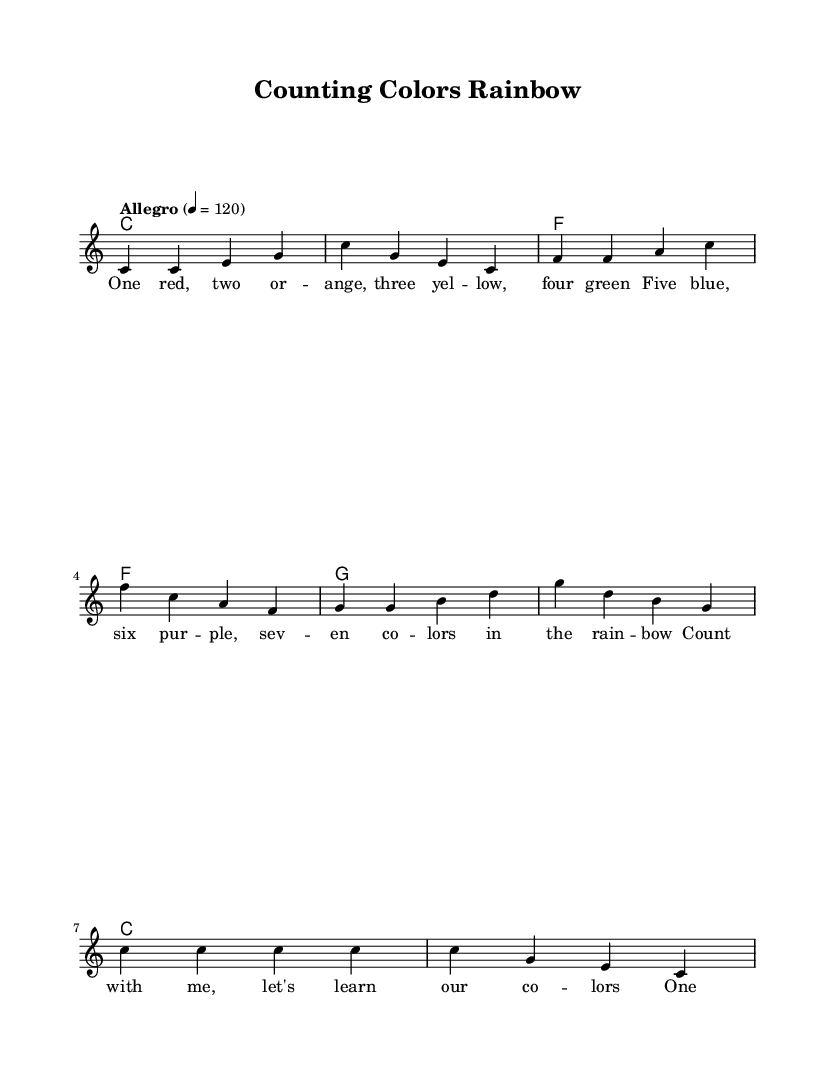What is the key signature of this music? The key signature is C major, which has no sharps or flats.
Answer: C major What is the time signature of this piece? The time signature is indicated at the beginning of the score as 4/4, which means there are four beats in each measure.
Answer: 4/4 What is the tempo marking for this music? The tempo marking is "Allegro" with a metronome marking of 120 beats per minute.
Answer: Allegro How many notes are in the first measure? The first measure contains four notes (c, c, e, g), which matches the time signature of 4/4 that indicates four beats in the measure.
Answer: Four What is the last chord of the piece? The last chord is a C major chord, which aligns with the note and chord structure shown in the harmonies section.
Answer: C How many colors are mentioned in the lyrics? The lyrics mention seven colors (red, orange, yellow, green, blue, purple), which students can count along with the melody.
Answer: Seven What educational concept does this song primarily teach? The song teaches colors and counting, as evident from both the lyrics and the repetitive structure aimed at reinforcing these concepts.
Answer: Colors and counting 